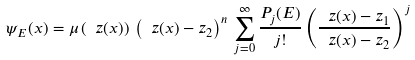<formula> <loc_0><loc_0><loc_500><loc_500>\psi _ { E } ( x ) = \mu \left ( \ z ( x ) \right ) \, \left ( \ z ( x ) - z _ { 2 } \right ) ^ { n } \, \sum _ { j = 0 } ^ { \infty } \frac { P _ { j } ( E ) } { j ! } \left ( \frac { \ z ( x ) - z _ { 1 } } { \ z ( x ) - z _ { 2 } } \right ) ^ { j }</formula> 